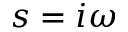<formula> <loc_0><loc_0><loc_500><loc_500>s = i \omega</formula> 